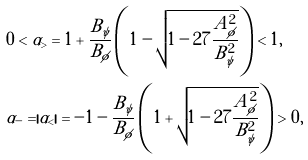<formula> <loc_0><loc_0><loc_500><loc_500>& 0 < \alpha _ { > } = 1 + \frac { B _ { \psi } } { B _ { \phi } } \left ( 1 - \sqrt { 1 - 2 7 \frac { A _ { \phi } ^ { 2 } } { B _ { \psi } ^ { 2 } } } \right ) < 1 , \\ & \alpha _ { - } = | \alpha _ { < } | = - 1 - \frac { B _ { \psi } } { B _ { \phi } } \left ( 1 + \sqrt { 1 - 2 7 \frac { A _ { \phi } ^ { 2 } } { B _ { \psi } ^ { 2 } } } \right ) > 0 ,</formula> 